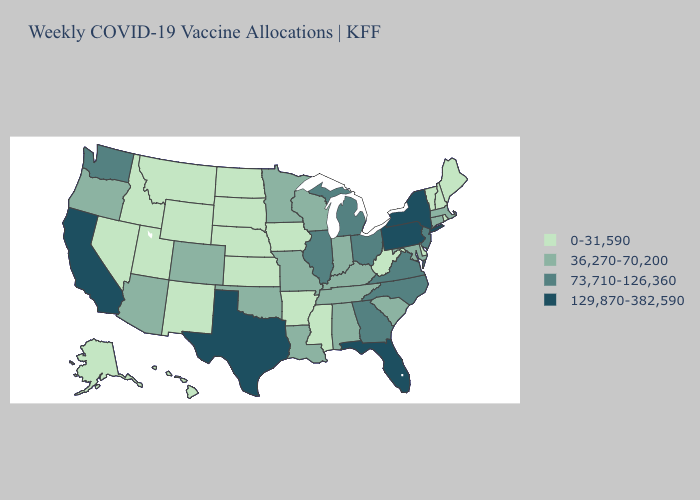Name the states that have a value in the range 73,710-126,360?
Short answer required. Georgia, Illinois, Michigan, New Jersey, North Carolina, Ohio, Virginia, Washington. What is the highest value in the South ?
Concise answer only. 129,870-382,590. Name the states that have a value in the range 129,870-382,590?
Answer briefly. California, Florida, New York, Pennsylvania, Texas. Which states have the lowest value in the USA?
Concise answer only. Alaska, Arkansas, Delaware, Hawaii, Idaho, Iowa, Kansas, Maine, Mississippi, Montana, Nebraska, Nevada, New Hampshire, New Mexico, North Dakota, Rhode Island, South Dakota, Utah, Vermont, West Virginia, Wyoming. What is the value of Alaska?
Concise answer only. 0-31,590. Does Maine have the lowest value in the Northeast?
Concise answer only. Yes. What is the value of Delaware?
Write a very short answer. 0-31,590. Among the states that border Wyoming , which have the highest value?
Give a very brief answer. Colorado. Which states have the lowest value in the West?
Quick response, please. Alaska, Hawaii, Idaho, Montana, Nevada, New Mexico, Utah, Wyoming. Does Virginia have the highest value in the South?
Keep it brief. No. What is the value of Kentucky?
Keep it brief. 36,270-70,200. What is the value of Florida?
Quick response, please. 129,870-382,590. Among the states that border Nebraska , which have the highest value?
Answer briefly. Colorado, Missouri. Among the states that border California , which have the highest value?
Keep it brief. Arizona, Oregon. What is the value of Wyoming?
Be succinct. 0-31,590. 